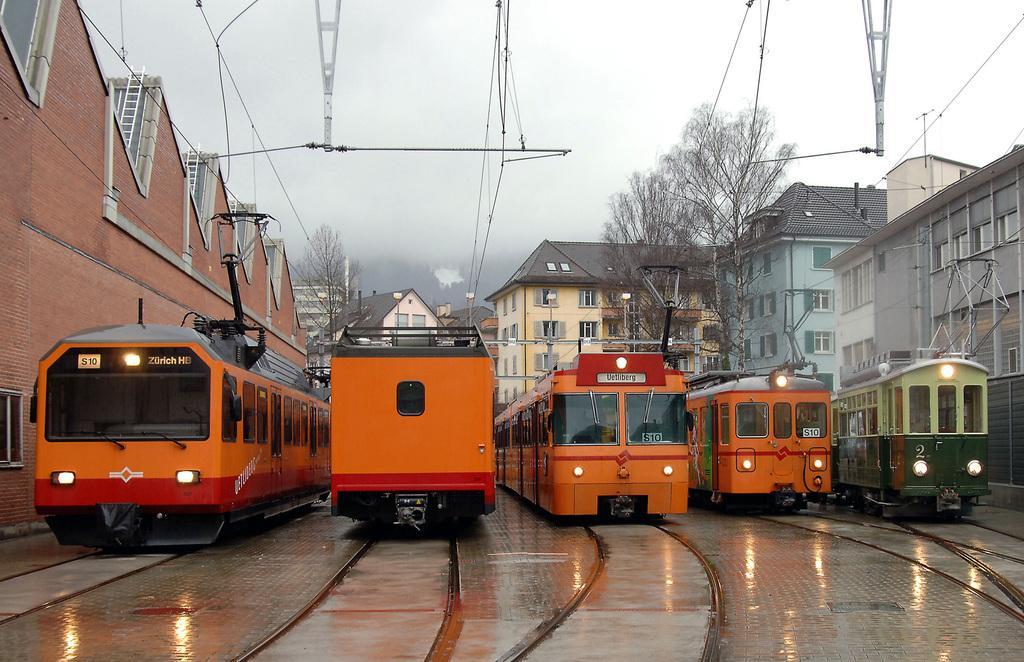In one or two sentences, can you explain what this image depicts? Here in this picture we can see number of trains present on the tracks, which are present on the ground and we can see those are connected with the electric wires passing through the poles and beside that on either side we can see number of houses and buildings with windows and doors present and we can also see trees present and we can see the sky is cloudy and in the far we can see fog covered over there. 